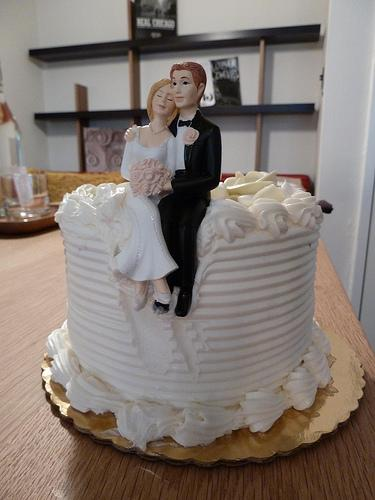Evaluate the image's quality based on the identified objects' positioning and sizing. The image appears to have a quality that is satisfactory, as the objects are well-positioned and appropriately sized, enabling a clear visualization of the main subject and related elements. Considering all the objects in the image, what complex reasoning task could be associated with their relationships? Understanding the process and importance of each object in a wedding celebration and analyzing the spatial arrangement of the wedding cake, decorations, drinkware, and backdrop to deduce the overall atmosphere of the event. What sentimental attributes does the image have, and elaborate on any specific features? The image evokes a feeling of love and celebration, mainly due to the beautiful wedding cake featuring loving bride and groom figurines and a romantic pink bouquet, set before a backdrop of white walls. Analyze how the objects in the image are interacting with one another, particularly focusing on the wedding theme. The wedding cake, with bride and groom figurines along with the pink bouquet, is the central object, supported by the cardboard stand. Glasses and champagne bottle signify a celebration, while the smudged white frosting conveys human touch. How many items related to the wedding are there in the image? Include objects with religious and celebratory symbolism. There are 19 objects related to the wedding, including the cake, bride and groom figurines, pink bouquet, gold foil, glasses, champagne bottle, frosting, cardboard stand, and icing smudge. What type of fruit is displayed in the fruit bowl near the wedding cake?  No, it's not mentioned in the image. Find the green balloon floating in the corner of the room. This instruction is misleading since there is no evidence of any balloons in the given objects. Check if the blue curtains in the background are open or closed. This instruction is misleading because there is no reference to curtains at all in the given objects. Identify the brand of the television on the black bookshelf. This instruction is misleading since it mentions a television that isn't present in the image. How many candles are lit on the birthday cake in the center of the table?  This is a misleading instruction, as it refers to a birthday cake instead of a wedding cake, which is the main object in the image. 